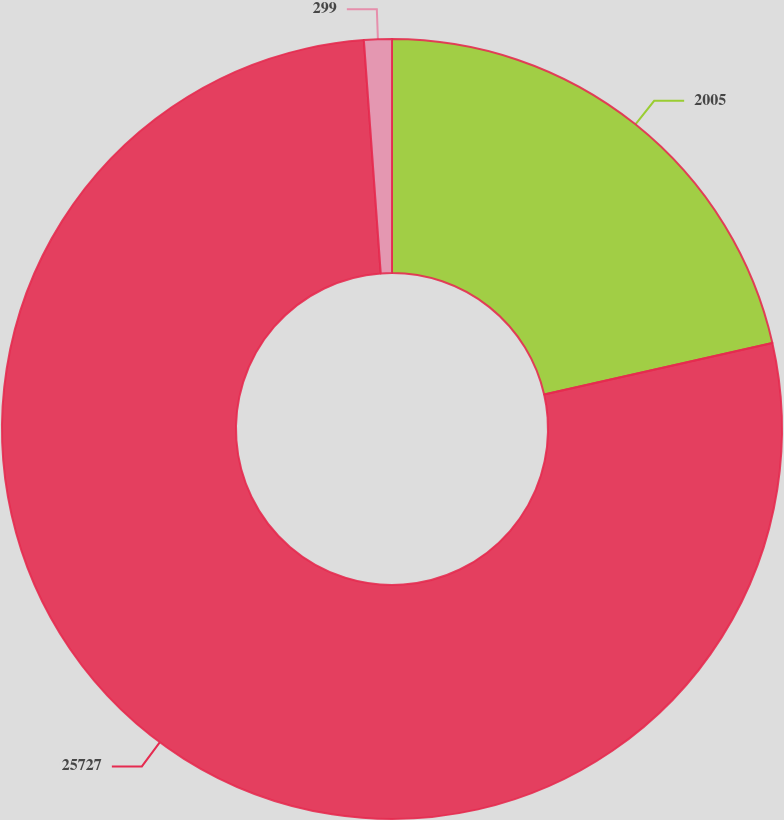<chart> <loc_0><loc_0><loc_500><loc_500><pie_chart><fcel>2005<fcel>25727<fcel>299<nl><fcel>21.46%<fcel>77.4%<fcel>1.15%<nl></chart> 